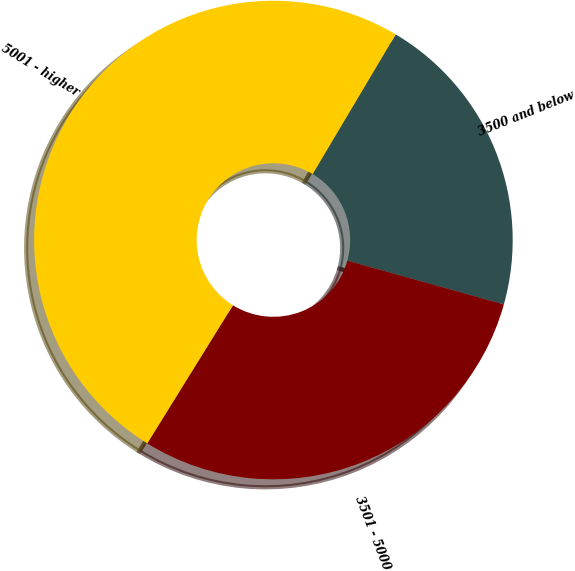Convert chart. <chart><loc_0><loc_0><loc_500><loc_500><pie_chart><fcel>3500 and below<fcel>3501 - 5000<fcel>5001 - higher<nl><fcel>20.8%<fcel>29.5%<fcel>49.7%<nl></chart> 